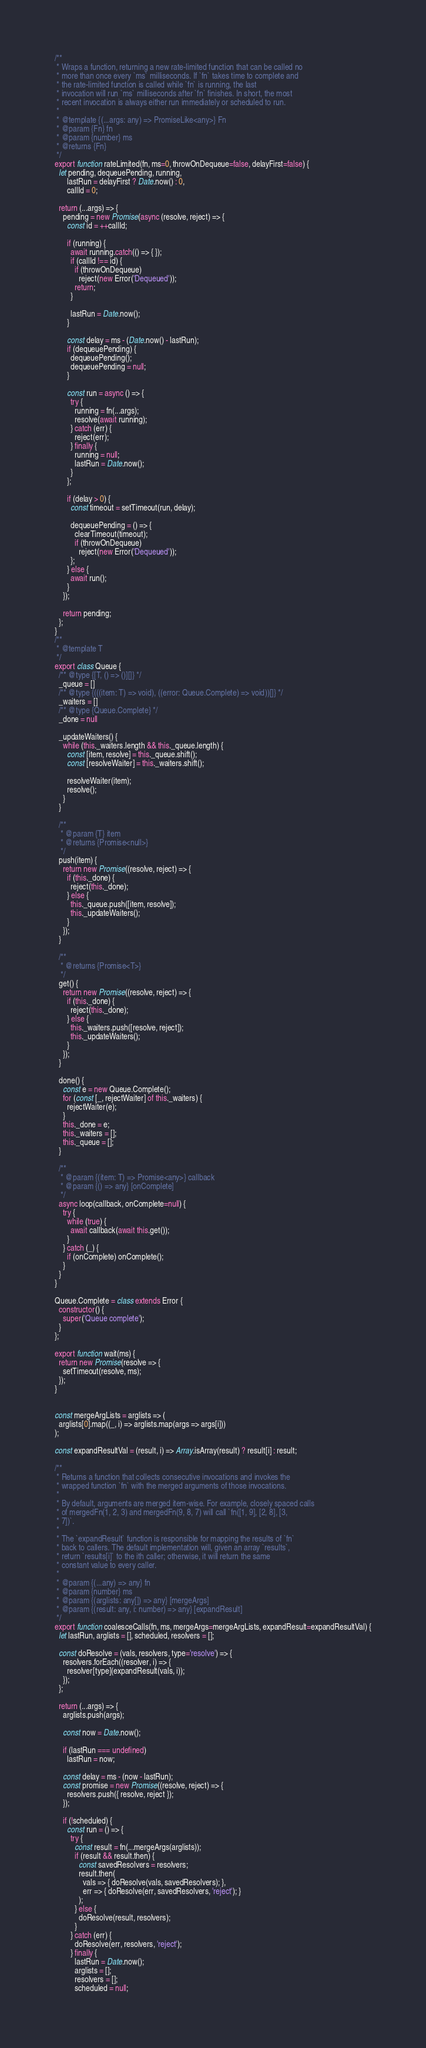<code> <loc_0><loc_0><loc_500><loc_500><_JavaScript_>/**
 * Wraps a function, returning a new rate-limited function that can be called no
 * more than once every `ms` milliseconds. If `fn` takes time to complete and
 * the rate-limited function is called while `fn` is running, the last
 * invocation will run `ms` milliseconds after `fn` finishes. In short, the most
 * recent invocation is always either run immediately or scheduled to run.
 *
 * @template {(...args: any) => PromiseLike<any>} Fn
 * @param {Fn} fn
 * @param {number} ms
 * @returns {Fn}
 */
export function rateLimited(fn, ms=0, throwOnDequeue=false, delayFirst=false) {
  let pending, dequeuePending, running,
      lastRun = delayFirst ? Date.now() : 0,
      callId = 0;

  return (...args) => {
    pending = new Promise(async (resolve, reject) => {
      const id = ++callId;

      if (running) {
        await running.catch(() => { });
        if (callId !== id) {
          if (throwOnDequeue)
            reject(new Error('Dequeued'));
          return;
        }

        lastRun = Date.now();
      }

      const delay = ms - (Date.now() - lastRun);
      if (dequeuePending) {
        dequeuePending();
        dequeuePending = null;
      }

      const run = async () => {
        try {
          running = fn(...args);
          resolve(await running);
        } catch (err) {
          reject(err);
        } finally {
          running = null;
          lastRun = Date.now();
        }
      };

      if (delay > 0) {
        const timeout = setTimeout(run, delay);

        dequeuePending = () => {
          clearTimeout(timeout);
          if (throwOnDequeue)
            reject(new Error('Dequeued'));
        };
      } else {
        await run();
      }
    });

    return pending;
  };
}
/**
 * @template T
 */
export class Queue {
  /** @type {[T, () => ()][]} */
  _queue = []
  /** @type {(((item: T) => void), ((error: Queue.Complete) => void))[]} */
  _waiters = []
  /** @type {Queue.Complete} */
  _done = null

  _updateWaiters() {
    while (this._waiters.length && this._queue.length) {
      const [item, resolve] = this._queue.shift();
      const [resolveWaiter] = this._waiters.shift();

      resolveWaiter(item);
      resolve();
    }
  }

  /**
   * @param {T} item
   * @returns {Promise<null>}
   */
  push(item) {
    return new Promise((resolve, reject) => {
      if (this._done) {
        reject(this._done);
      } else {
        this._queue.push([item, resolve]);
        this._updateWaiters();
      }
    });
  }

  /**
   * @returns {Promise<T>}
   */
  get() {
    return new Promise((resolve, reject) => {
      if (this._done) {
        reject(this._done);
      } else {
        this._waiters.push([resolve, reject]);
        this._updateWaiters();
      }
    });
  }

  done() {
    const e = new Queue.Complete();
    for (const [_, rejectWaiter] of this._waiters) {
      rejectWaiter(e);
    }
    this._done = e;
    this._waiters = [];
    this._queue = [];
  }

  /**
   * @param {(item: T) => Promise<any>} callback
   * @param {() => any} [onComplete]
   */
  async loop(callback, onComplete=null) {
    try {
      while (true) {
        await callback(await this.get());
      }
    } catch (_) {
      if (onComplete) onComplete();
    }
  }
}

Queue.Complete = class extends Error {
  constructor() {
    super('Queue complete');
  }
};

export function wait(ms) {
  return new Promise(resolve => {
    setTimeout(resolve, ms);
  });
}


const mergeArgLists = arglists => (
  arglists[0].map((_, i) => arglists.map(args => args[i]))
);

const expandResultVal = (result, i) => Array.isArray(result) ? result[i] : result;

/**
 * Returns a function that collects consecutive invocations and invokes the
 * wrapped function `fn` with the merged arguments of those invocations.
 *
 * By default, arguments are merged item-wise. For example, closely spaced calls
 * of mergedFn(1, 2, 3) and mergedFn(9, 8, 7) will call `fn([1, 9], [2, 8], [3,
 * 7])`.
 *
 * The `expandResult` function is responsible for mapping the results of `fn`
 * back to callers. The default implementation will, given an array `results`,
 * return `results[i]` to the ith caller; otherwise, it will return the same
 * constant value to every caller.
 *
 * @param {(...any) => any} fn
 * @param {number} ms
 * @param {(arglists: any[]) => any} [mergeArgs]
 * @param {(result: any, i: number) => any} [expandResult]
 */
export function coalesceCalls(fn, ms, mergeArgs=mergeArgLists, expandResult=expandResultVal) {
  let lastRun, arglists = [], scheduled, resolvers = [];

  const doResolve = (vals, resolvers, type='resolve') => {
    resolvers.forEach((resolver, i) => {
      resolver[type](expandResult(vals, i));
    });
  };

  return (...args) => {
    arglists.push(args);

    const now = Date.now();

    if (lastRun === undefined)
      lastRun = now;

    const delay = ms - (now - lastRun);
    const promise = new Promise((resolve, reject) => {
      resolvers.push({ resolve, reject });
    });

    if (!scheduled) {
      const run = () => {
        try {
          const result = fn(...mergeArgs(arglists));
          if (result && result.then) {
            const savedResolvers = resolvers;
            result.then(
              vals => { doResolve(vals, savedResolvers); },
              err => { doResolve(err, savedResolvers, 'reject'); }
            );
          } else {
            doResolve(result, resolvers);
          }
        } catch (err) {
          doResolve(err, resolvers, 'reject');
        } finally {
          lastRun = Date.now();
          arglists = [];
          resolvers = [];
          scheduled = null;</code> 